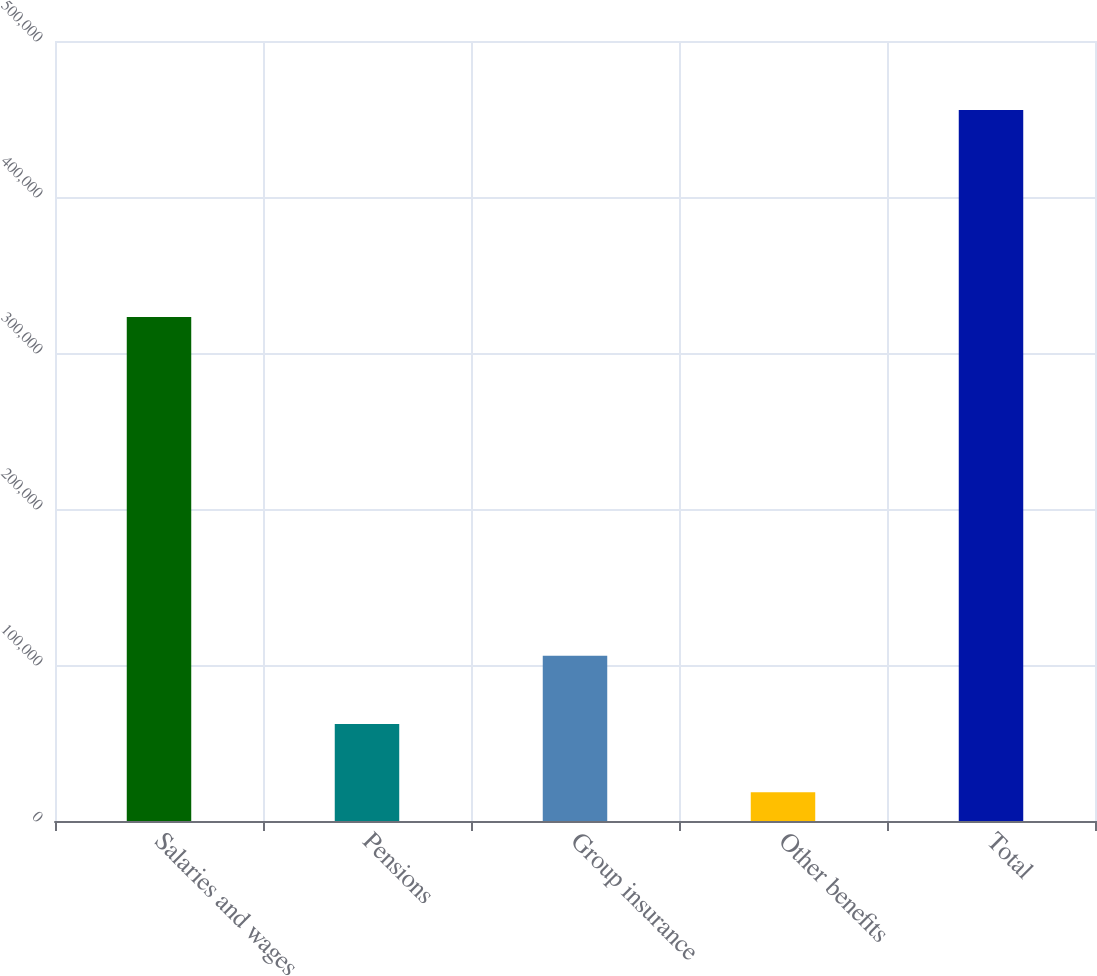Convert chart to OTSL. <chart><loc_0><loc_0><loc_500><loc_500><bar_chart><fcel>Salaries and wages<fcel>Pensions<fcel>Group insurance<fcel>Other benefits<fcel>Total<nl><fcel>323022<fcel>62148.8<fcel>105876<fcel>18422<fcel>455690<nl></chart> 